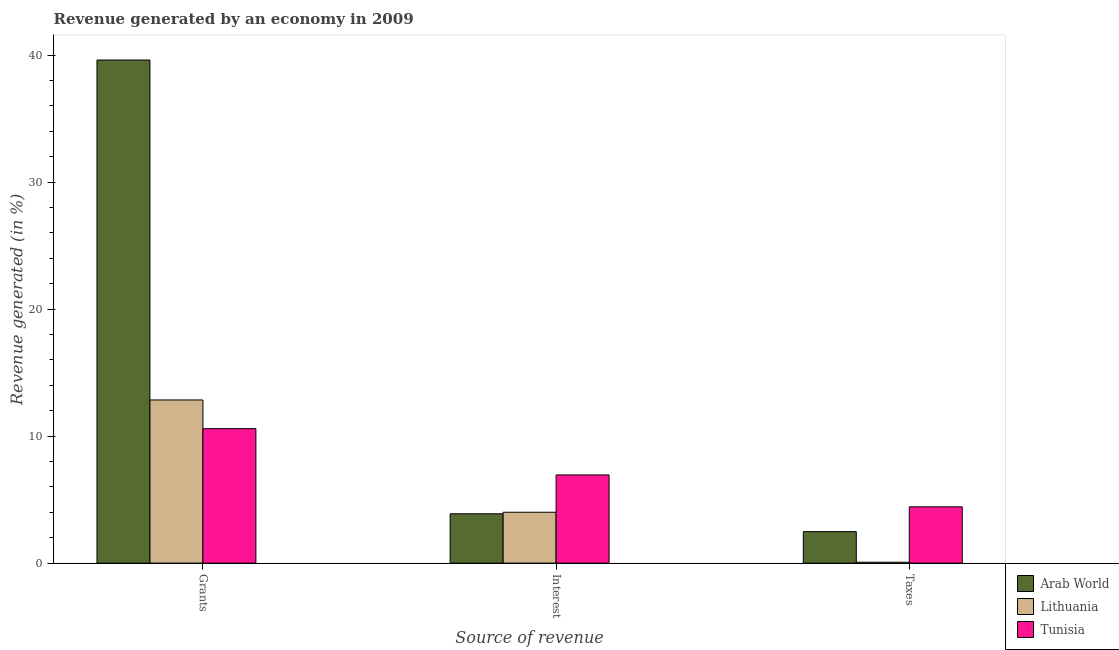How many different coloured bars are there?
Your response must be concise. 3. Are the number of bars on each tick of the X-axis equal?
Make the answer very short. Yes. How many bars are there on the 3rd tick from the left?
Ensure brevity in your answer.  3. What is the label of the 1st group of bars from the left?
Your answer should be very brief. Grants. What is the percentage of revenue generated by grants in Lithuania?
Provide a short and direct response. 12.85. Across all countries, what is the maximum percentage of revenue generated by taxes?
Provide a succinct answer. 4.43. Across all countries, what is the minimum percentage of revenue generated by taxes?
Your answer should be compact. 0.07. In which country was the percentage of revenue generated by taxes maximum?
Your response must be concise. Tunisia. In which country was the percentage of revenue generated by taxes minimum?
Make the answer very short. Lithuania. What is the total percentage of revenue generated by grants in the graph?
Offer a terse response. 63.05. What is the difference between the percentage of revenue generated by taxes in Arab World and that in Lithuania?
Your answer should be very brief. 2.41. What is the difference between the percentage of revenue generated by grants in Tunisia and the percentage of revenue generated by interest in Lithuania?
Offer a very short reply. 6.58. What is the average percentage of revenue generated by interest per country?
Your answer should be very brief. 4.94. What is the difference between the percentage of revenue generated by taxes and percentage of revenue generated by grants in Tunisia?
Make the answer very short. -6.16. What is the ratio of the percentage of revenue generated by grants in Arab World to that in Lithuania?
Your response must be concise. 3.08. Is the percentage of revenue generated by interest in Arab World less than that in Tunisia?
Make the answer very short. Yes. What is the difference between the highest and the second highest percentage of revenue generated by taxes?
Provide a succinct answer. 1.95. What is the difference between the highest and the lowest percentage of revenue generated by interest?
Ensure brevity in your answer.  3.06. Is the sum of the percentage of revenue generated by grants in Tunisia and Lithuania greater than the maximum percentage of revenue generated by interest across all countries?
Provide a short and direct response. Yes. What does the 1st bar from the left in Taxes represents?
Offer a very short reply. Arab World. What does the 1st bar from the right in Interest represents?
Provide a succinct answer. Tunisia. Is it the case that in every country, the sum of the percentage of revenue generated by grants and percentage of revenue generated by interest is greater than the percentage of revenue generated by taxes?
Provide a short and direct response. Yes. How many bars are there?
Make the answer very short. 9. How are the legend labels stacked?
Offer a terse response. Vertical. What is the title of the graph?
Ensure brevity in your answer.  Revenue generated by an economy in 2009. Does "Morocco" appear as one of the legend labels in the graph?
Make the answer very short. No. What is the label or title of the X-axis?
Offer a very short reply. Source of revenue. What is the label or title of the Y-axis?
Your response must be concise. Revenue generated (in %). What is the Revenue generated (in %) of Arab World in Grants?
Your response must be concise. 39.62. What is the Revenue generated (in %) in Lithuania in Grants?
Your answer should be very brief. 12.85. What is the Revenue generated (in %) in Tunisia in Grants?
Ensure brevity in your answer.  10.59. What is the Revenue generated (in %) of Arab World in Interest?
Keep it short and to the point. 3.88. What is the Revenue generated (in %) of Lithuania in Interest?
Your response must be concise. 4. What is the Revenue generated (in %) of Tunisia in Interest?
Provide a short and direct response. 6.94. What is the Revenue generated (in %) of Arab World in Taxes?
Provide a short and direct response. 2.48. What is the Revenue generated (in %) in Lithuania in Taxes?
Keep it short and to the point. 0.07. What is the Revenue generated (in %) in Tunisia in Taxes?
Give a very brief answer. 4.43. Across all Source of revenue, what is the maximum Revenue generated (in %) of Arab World?
Your answer should be compact. 39.62. Across all Source of revenue, what is the maximum Revenue generated (in %) of Lithuania?
Make the answer very short. 12.85. Across all Source of revenue, what is the maximum Revenue generated (in %) in Tunisia?
Ensure brevity in your answer.  10.59. Across all Source of revenue, what is the minimum Revenue generated (in %) of Arab World?
Your response must be concise. 2.48. Across all Source of revenue, what is the minimum Revenue generated (in %) in Lithuania?
Offer a very short reply. 0.07. Across all Source of revenue, what is the minimum Revenue generated (in %) of Tunisia?
Ensure brevity in your answer.  4.43. What is the total Revenue generated (in %) in Arab World in the graph?
Ensure brevity in your answer.  45.98. What is the total Revenue generated (in %) in Lithuania in the graph?
Provide a short and direct response. 16.92. What is the total Revenue generated (in %) of Tunisia in the graph?
Offer a terse response. 21.97. What is the difference between the Revenue generated (in %) in Arab World in Grants and that in Interest?
Give a very brief answer. 35.73. What is the difference between the Revenue generated (in %) of Lithuania in Grants and that in Interest?
Your response must be concise. 8.84. What is the difference between the Revenue generated (in %) of Tunisia in Grants and that in Interest?
Give a very brief answer. 3.65. What is the difference between the Revenue generated (in %) in Arab World in Grants and that in Taxes?
Offer a terse response. 37.14. What is the difference between the Revenue generated (in %) in Lithuania in Grants and that in Taxes?
Your answer should be compact. 12.78. What is the difference between the Revenue generated (in %) of Tunisia in Grants and that in Taxes?
Your answer should be compact. 6.16. What is the difference between the Revenue generated (in %) in Arab World in Interest and that in Taxes?
Ensure brevity in your answer.  1.4. What is the difference between the Revenue generated (in %) in Lithuania in Interest and that in Taxes?
Give a very brief answer. 3.94. What is the difference between the Revenue generated (in %) in Tunisia in Interest and that in Taxes?
Your response must be concise. 2.51. What is the difference between the Revenue generated (in %) in Arab World in Grants and the Revenue generated (in %) in Lithuania in Interest?
Give a very brief answer. 35.61. What is the difference between the Revenue generated (in %) of Arab World in Grants and the Revenue generated (in %) of Tunisia in Interest?
Your response must be concise. 32.67. What is the difference between the Revenue generated (in %) in Lithuania in Grants and the Revenue generated (in %) in Tunisia in Interest?
Give a very brief answer. 5.9. What is the difference between the Revenue generated (in %) of Arab World in Grants and the Revenue generated (in %) of Lithuania in Taxes?
Your response must be concise. 39.55. What is the difference between the Revenue generated (in %) in Arab World in Grants and the Revenue generated (in %) in Tunisia in Taxes?
Provide a succinct answer. 35.18. What is the difference between the Revenue generated (in %) of Lithuania in Grants and the Revenue generated (in %) of Tunisia in Taxes?
Provide a short and direct response. 8.42. What is the difference between the Revenue generated (in %) in Arab World in Interest and the Revenue generated (in %) in Lithuania in Taxes?
Offer a very short reply. 3.82. What is the difference between the Revenue generated (in %) of Arab World in Interest and the Revenue generated (in %) of Tunisia in Taxes?
Give a very brief answer. -0.55. What is the difference between the Revenue generated (in %) of Lithuania in Interest and the Revenue generated (in %) of Tunisia in Taxes?
Provide a succinct answer. -0.43. What is the average Revenue generated (in %) of Arab World per Source of revenue?
Provide a succinct answer. 15.33. What is the average Revenue generated (in %) in Lithuania per Source of revenue?
Your answer should be compact. 5.64. What is the average Revenue generated (in %) in Tunisia per Source of revenue?
Provide a succinct answer. 7.32. What is the difference between the Revenue generated (in %) in Arab World and Revenue generated (in %) in Lithuania in Grants?
Provide a succinct answer. 26.77. What is the difference between the Revenue generated (in %) in Arab World and Revenue generated (in %) in Tunisia in Grants?
Provide a succinct answer. 29.03. What is the difference between the Revenue generated (in %) of Lithuania and Revenue generated (in %) of Tunisia in Grants?
Offer a very short reply. 2.26. What is the difference between the Revenue generated (in %) in Arab World and Revenue generated (in %) in Lithuania in Interest?
Your answer should be very brief. -0.12. What is the difference between the Revenue generated (in %) of Arab World and Revenue generated (in %) of Tunisia in Interest?
Make the answer very short. -3.06. What is the difference between the Revenue generated (in %) of Lithuania and Revenue generated (in %) of Tunisia in Interest?
Offer a terse response. -2.94. What is the difference between the Revenue generated (in %) in Arab World and Revenue generated (in %) in Lithuania in Taxes?
Give a very brief answer. 2.41. What is the difference between the Revenue generated (in %) in Arab World and Revenue generated (in %) in Tunisia in Taxes?
Your response must be concise. -1.95. What is the difference between the Revenue generated (in %) in Lithuania and Revenue generated (in %) in Tunisia in Taxes?
Offer a terse response. -4.37. What is the ratio of the Revenue generated (in %) of Arab World in Grants to that in Interest?
Provide a short and direct response. 10.2. What is the ratio of the Revenue generated (in %) in Lithuania in Grants to that in Interest?
Ensure brevity in your answer.  3.21. What is the ratio of the Revenue generated (in %) in Tunisia in Grants to that in Interest?
Ensure brevity in your answer.  1.52. What is the ratio of the Revenue generated (in %) of Arab World in Grants to that in Taxes?
Your response must be concise. 15.98. What is the ratio of the Revenue generated (in %) of Lithuania in Grants to that in Taxes?
Offer a terse response. 190.44. What is the ratio of the Revenue generated (in %) of Tunisia in Grants to that in Taxes?
Your answer should be compact. 2.39. What is the ratio of the Revenue generated (in %) in Arab World in Interest to that in Taxes?
Offer a terse response. 1.57. What is the ratio of the Revenue generated (in %) in Lithuania in Interest to that in Taxes?
Provide a short and direct response. 59.36. What is the ratio of the Revenue generated (in %) in Tunisia in Interest to that in Taxes?
Keep it short and to the point. 1.57. What is the difference between the highest and the second highest Revenue generated (in %) in Arab World?
Your answer should be compact. 35.73. What is the difference between the highest and the second highest Revenue generated (in %) in Lithuania?
Keep it short and to the point. 8.84. What is the difference between the highest and the second highest Revenue generated (in %) in Tunisia?
Offer a terse response. 3.65. What is the difference between the highest and the lowest Revenue generated (in %) in Arab World?
Give a very brief answer. 37.14. What is the difference between the highest and the lowest Revenue generated (in %) in Lithuania?
Give a very brief answer. 12.78. What is the difference between the highest and the lowest Revenue generated (in %) in Tunisia?
Provide a succinct answer. 6.16. 